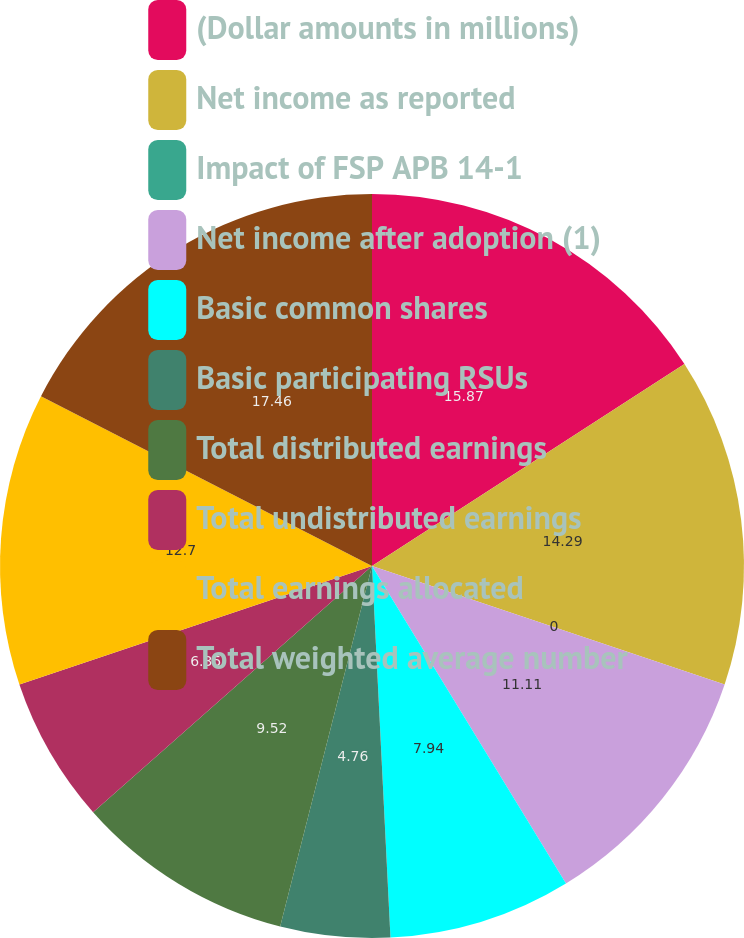Convert chart. <chart><loc_0><loc_0><loc_500><loc_500><pie_chart><fcel>(Dollar amounts in millions)<fcel>Net income as reported<fcel>Impact of FSP APB 14-1<fcel>Net income after adoption (1)<fcel>Basic common shares<fcel>Basic participating RSUs<fcel>Total distributed earnings<fcel>Total undistributed earnings<fcel>Total earnings allocated<fcel>Total weighted average number<nl><fcel>15.87%<fcel>14.29%<fcel>0.0%<fcel>11.11%<fcel>7.94%<fcel>4.76%<fcel>9.52%<fcel>6.35%<fcel>12.7%<fcel>17.46%<nl></chart> 